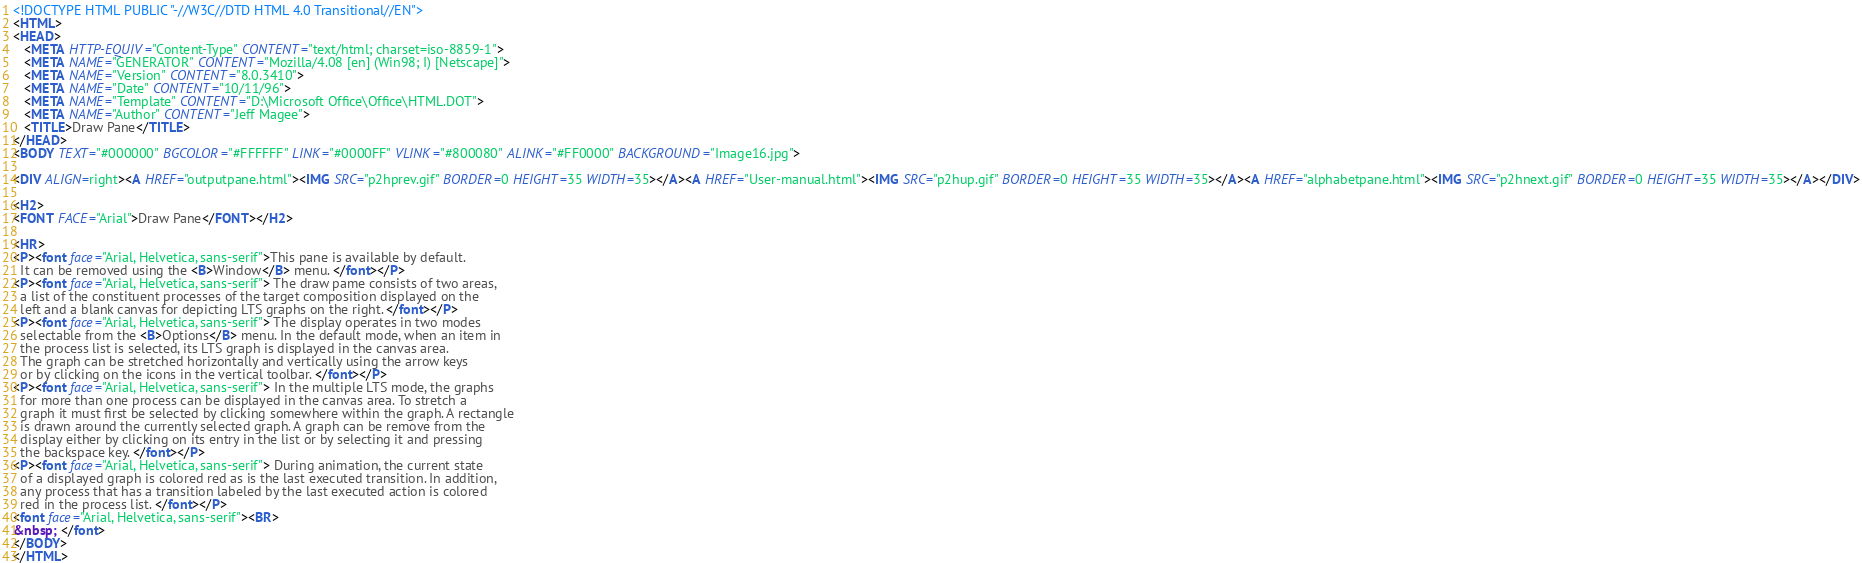Convert code to text. <code><loc_0><loc_0><loc_500><loc_500><_HTML_><!DOCTYPE HTML PUBLIC "-//W3C//DTD HTML 4.0 Transitional//EN">
<HTML>
<HEAD>
   <META HTTP-EQUIV="Content-Type" CONTENT="text/html; charset=iso-8859-1">
   <META NAME="GENERATOR" CONTENT="Mozilla/4.08 [en] (Win98; I) [Netscape]">
   <META NAME="Version" CONTENT="8.0.3410">
   <META NAME="Date" CONTENT="10/11/96">
   <META NAME="Template" CONTENT="D:\Microsoft Office\Office\HTML.DOT">
   <META NAME="Author" CONTENT="Jeff Magee">
   <TITLE>Draw Pane</TITLE>
</HEAD>
<BODY TEXT="#000000" BGCOLOR="#FFFFFF" LINK="#0000FF" VLINK="#800080" ALINK="#FF0000" BACKGROUND="Image16.jpg">

<DIV ALIGN=right><A HREF="outputpane.html"><IMG SRC="p2hprev.gif" BORDER=0 HEIGHT=35 WIDTH=35></A><A HREF="User-manual.html"><IMG SRC="p2hup.gif" BORDER=0 HEIGHT=35 WIDTH=35></A><A HREF="alphabetpane.html"><IMG SRC="p2hnext.gif" BORDER=0 HEIGHT=35 WIDTH=35></A></DIV>

<H2>
<FONT FACE="Arial">Draw Pane</FONT></H2>

<HR>
<P><font face="Arial, Helvetica, sans-serif">This pane is available by default. 
  It can be removed using the <B>Window</B> menu. </font></P>
<P><font face="Arial, Helvetica, sans-serif"> The draw pame consists of two areas, 
  a list of the constituent processes of the target composition displayed on the 
  left and a blank canvas for depicting LTS graphs on the right. </font></P>
<P><font face="Arial, Helvetica, sans-serif"> The display operates in two modes 
  selectable from the <B>Options</B> menu. In the default mode, when an item in 
  the process list is selected, its LTS graph is displayed in the canvas area. 
  The graph can be stretched horizontally and vertically using the arrow keys 
  or by clicking on the icons in the vertical toolbar. </font></P>
<P><font face="Arial, Helvetica, sans-serif"> In the multiple LTS mode, the graphs 
  for more than one process can be displayed in the canvas area. To stretch a 
  graph it must first be selected by clicking somewhere within the graph. A rectangle 
  is drawn around the currently selected graph. A graph can be remove from the 
  display either by clicking on its entry in the list or by selecting it and pressing 
  the backspace key. </font></P>
<P><font face="Arial, Helvetica, sans-serif"> During animation, the current state 
  of a displayed graph is colored red as is the last executed transition. In addition, 
  any process that has a transition labeled by the last executed action is colored 
  red in the process list. </font></P>
<font face="Arial, Helvetica, sans-serif"><BR>
&nbsp; </font>
</BODY>
</HTML>
</code> 